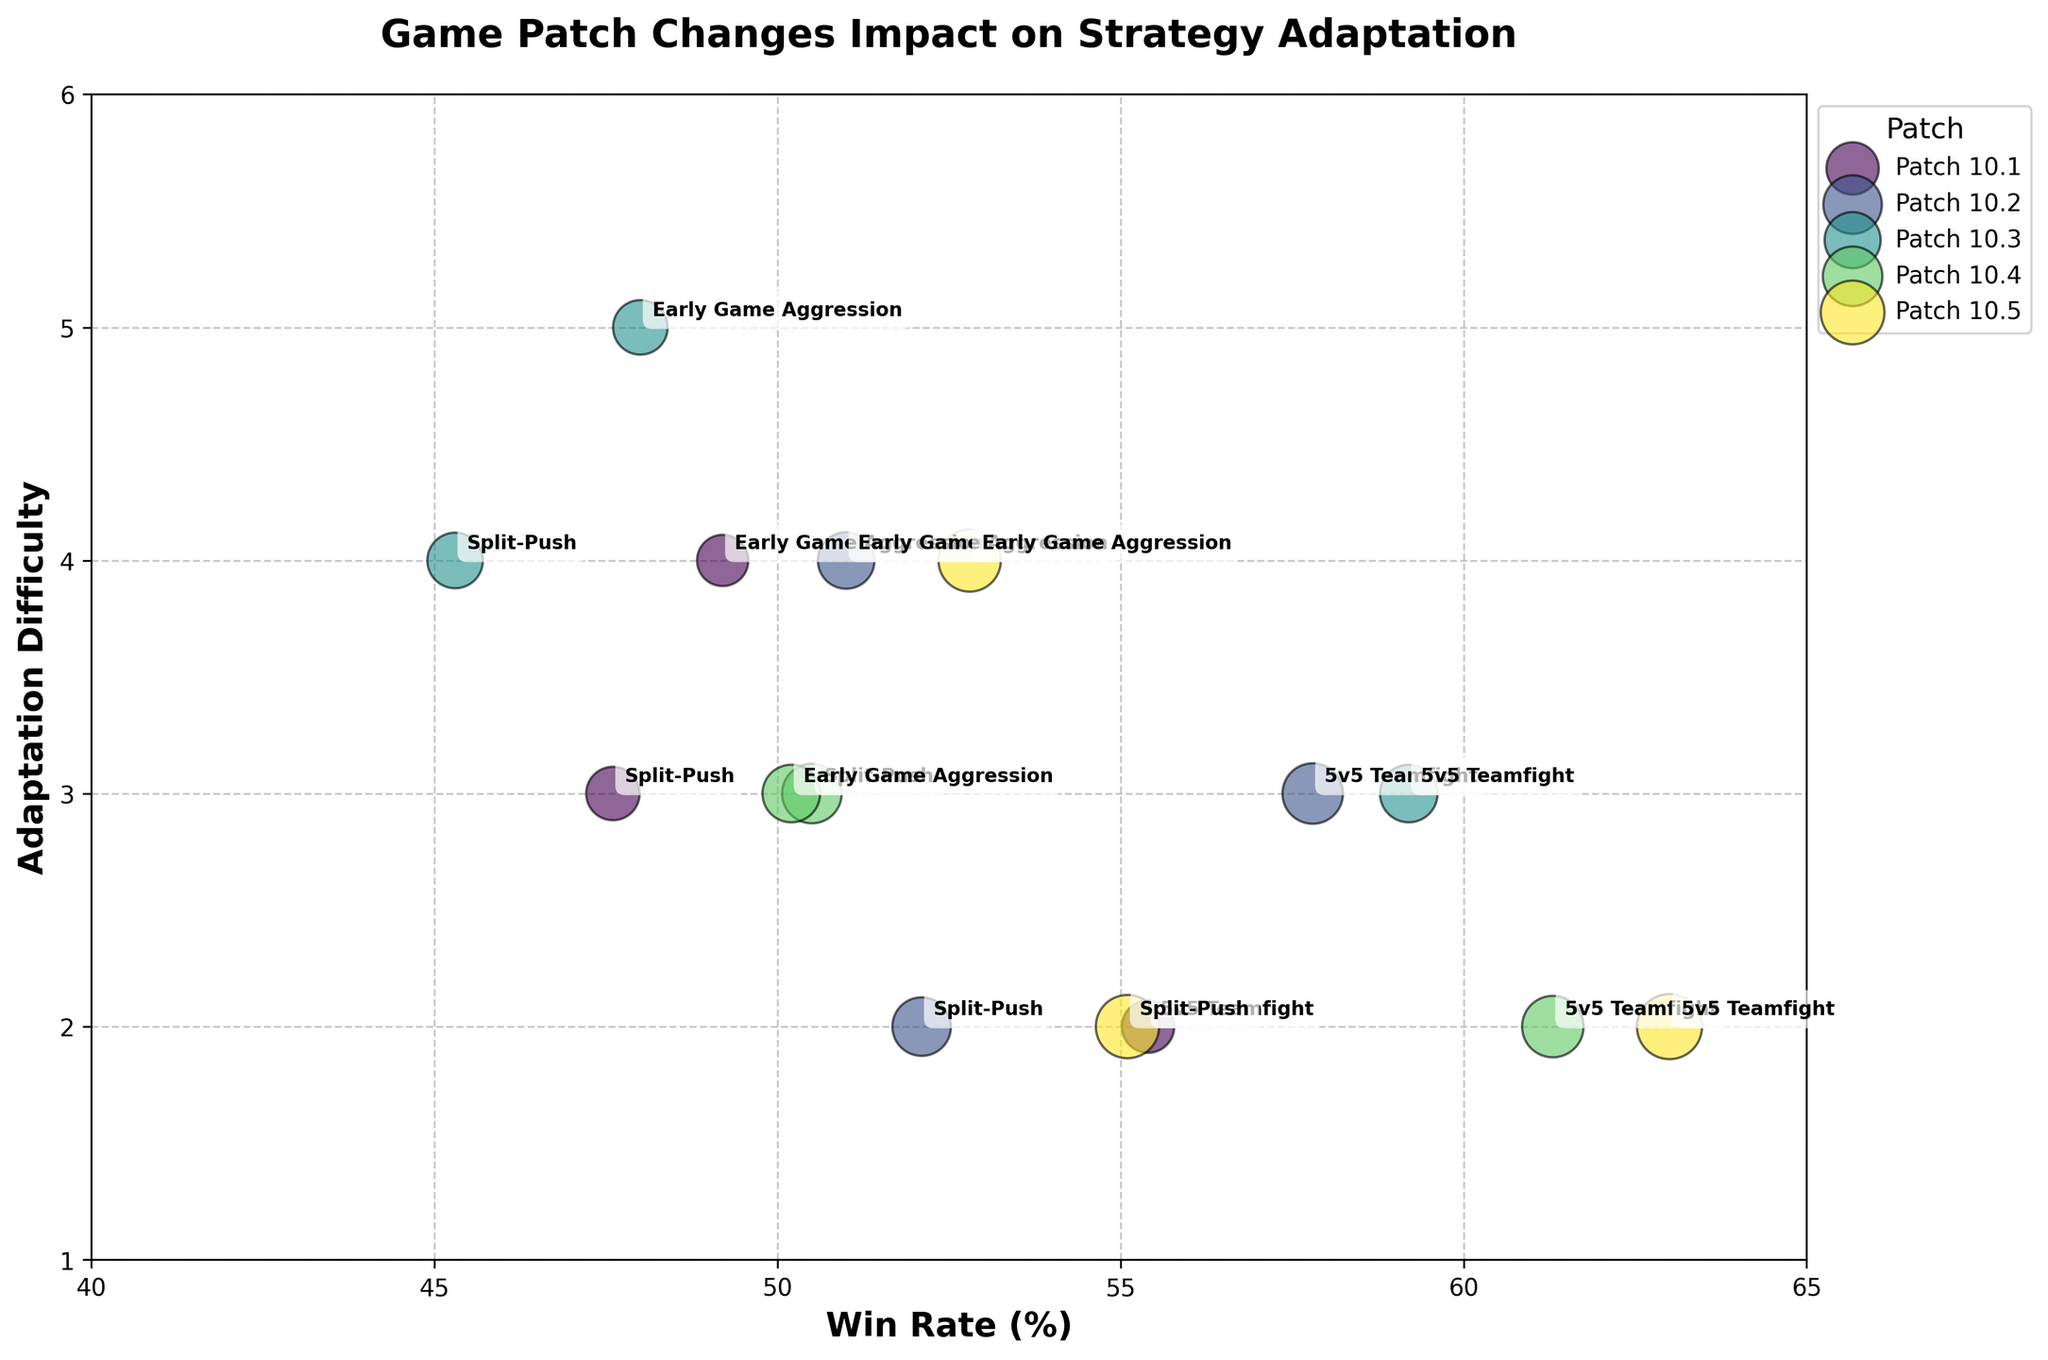What is the title of the plot? The title is displayed at the top of the plot which reads 'Game Patch Changes Impact on Strategy Adaptation.'
Answer: Game Patch Changes Impact on Strategy Adaptation Which strategy had the highest win rate in Patch 10.1? Look for the bubbles labeled as 'Patch 10.1' and identify the highest win rate. The strategy '5v5 Teamfight' has the highest win rate among them.
Answer: 5v5 Teamfight How many patches are represented in the plot? Each unique color represents a different patch in the legend. There are five patches listed from 10.1 to 10.5.
Answer: 5 What is the average win rate of the 'Split-Push' strategy across all patches? The win rates for 'Split-Push' from each patch are 47.6, 52.1, 45.3, 50.5, and 55.1. Summing these values gives 250.6. Dividing by the number of patches (5) provides the average win rate.
Answer: 50.1 Which patch showed the largest improvement in win rate for 'Early Game Aggression' compared to the previous patch? Compare the win rates for 'Early Game Aggression' strategy across consecutive patches: 10.1 (49.2), 10.2 (51.0), 10.3 (48.0), 10.4 (50.2), and 10.5 (52.8). The largest improvement is from 10.3 to 10.4.
Answer: Patch 10.5 How does the adaptation difficulty of '5v5 Teamfight' in Patch 10.2 compare to that in Patch 10.3? Find the adaptation difficulties for '5v5 Teamfight' in Patches 10.2 and 10.3. They are 3 and 3 respectively, showing no change.
Answer: Equal Which strategy had the most matches in Patch 10.4? Refer to the bubble sizes for Patch 10.4, and the largest bubble indicates the strategy with the most matches. '5v5 Teamfight' at 330 matches is the largest.
Answer: 5v5 Teamfight What is the trend in win rates for '5v5 Teamfight' from Patch 10.1 to Patch 10.5? List win rates for '5v5 Teamfight' across all patches: 55.4 (10.1), 57.8 (10.2), 59.2 (10.3), 61.3 (10.4), and 63.0 (10.5). The trend shows a consistent increase.
Answer: Increasing For which patches did 'Split-Push' require the least adaptation difficulty? Look for the lowest adaptation difficulty bubble for 'Split-Push'. Patch 10.2 and Patch 10.5 both have the lowest adaptation difficulty of 2.
Answer: Patches 10.2 and 10.5 Which strategy consistently had the highest adaptation difficulty? Identify the strategies with the highest adaptation difficulty across patches. 'Early Game Aggression' consistently shows higher values (4, 4, 5, 3, 4) than other strategies within the same patch.
Answer: Early Game Aggression 